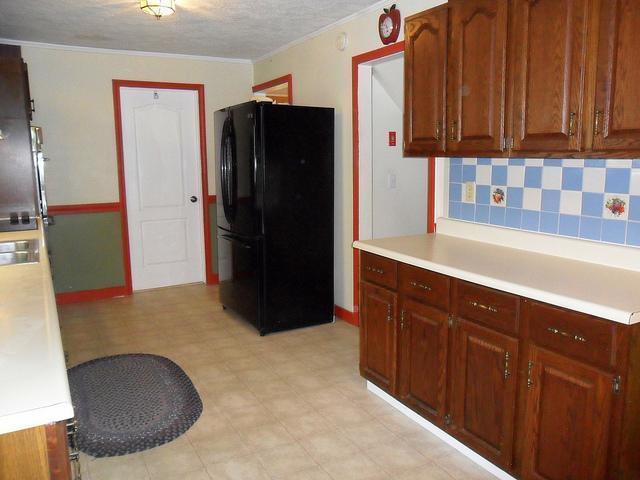What material is the floor made of?
Make your selection and explain in format: 'Answer: answer
Rationale: rationale.'
Options: Carpet, vinyl, wood, tile. Answer: vinyl.
Rationale: Vinyl floors create tile. 